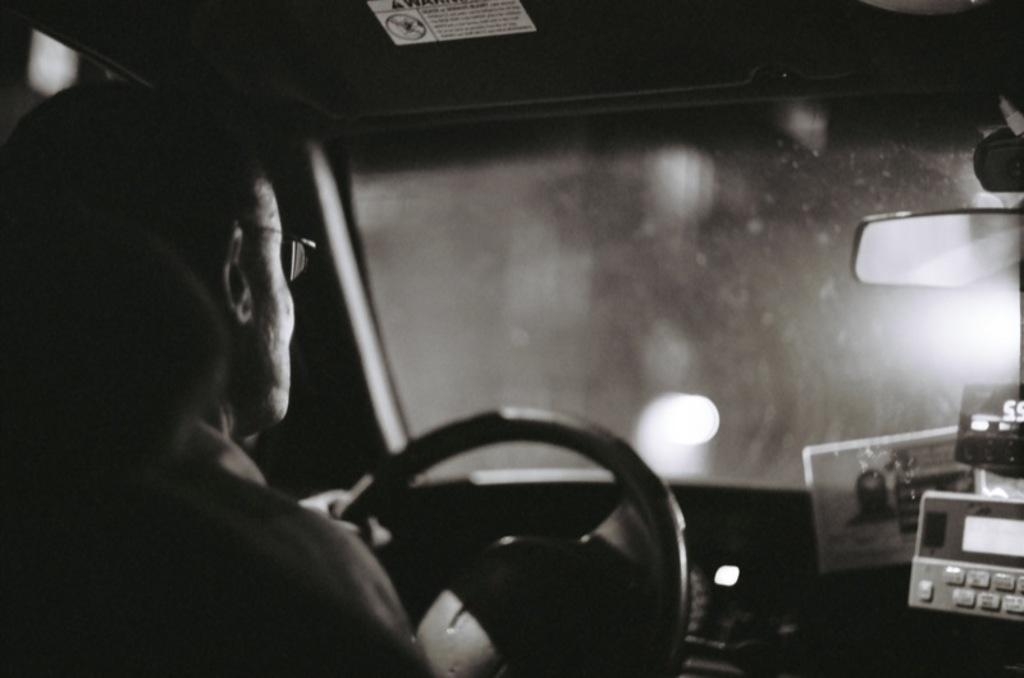What is the color scheme of the image? The image is black and white. Who is present in the image? There is a man in the image. Where is the man located in the image? The man is sitting inside a car. What type of cherries can be seen on the seat of the car in the image? There are no cherries present in the image; it is a black and white image of a man sitting inside a car. 